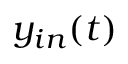Convert formula to latex. <formula><loc_0><loc_0><loc_500><loc_500>y _ { i n } ( t )</formula> 